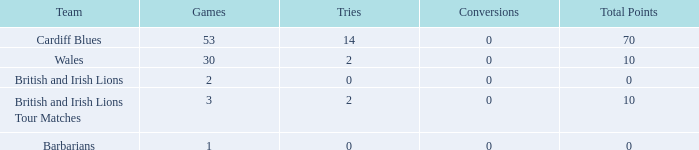What is the smallest number of tries with conversions more than 0? None. 